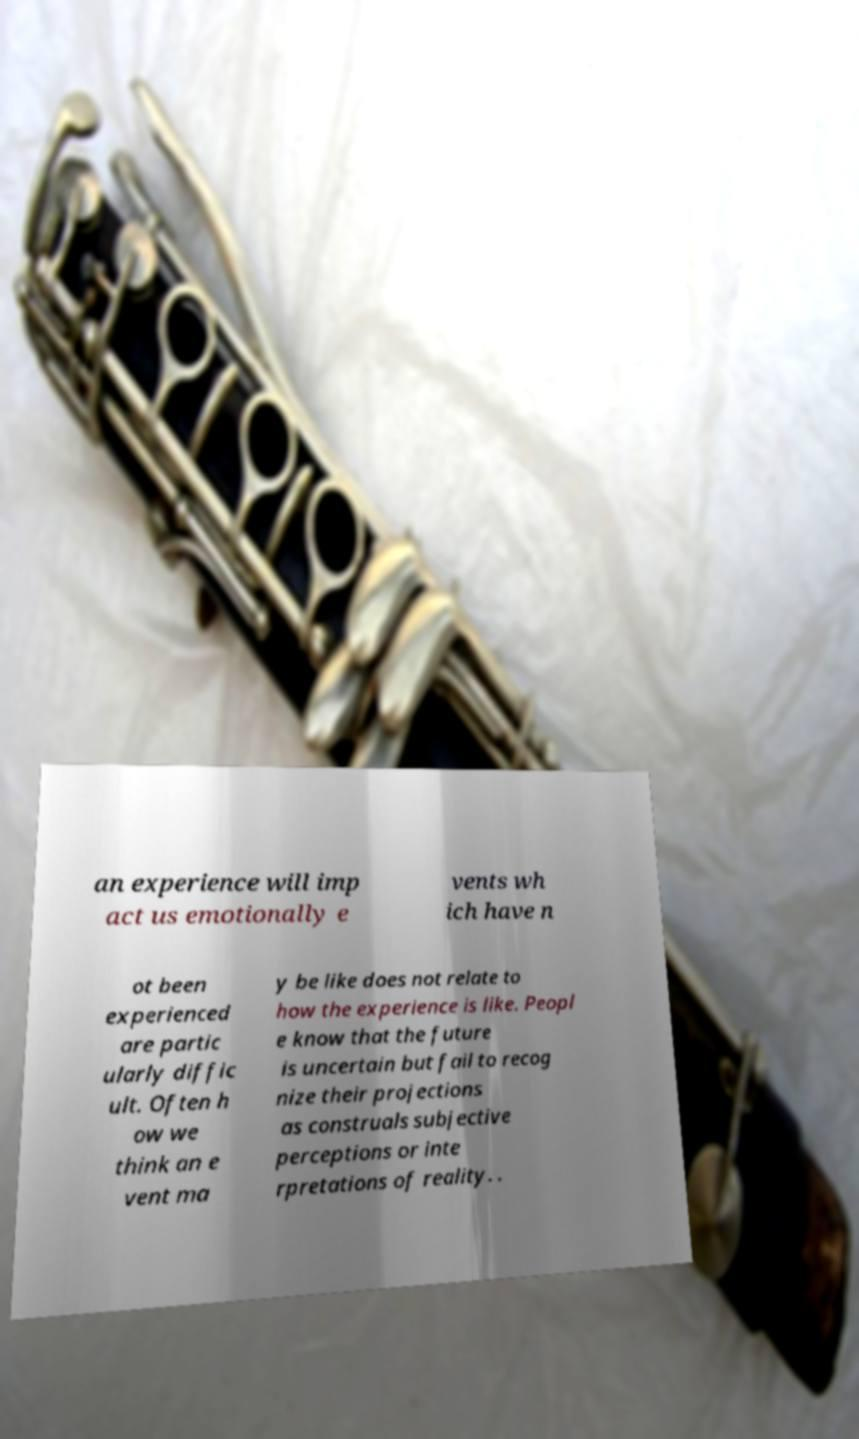Please identify and transcribe the text found in this image. an experience will imp act us emotionally e vents wh ich have n ot been experienced are partic ularly diffic ult. Often h ow we think an e vent ma y be like does not relate to how the experience is like. Peopl e know that the future is uncertain but fail to recog nize their projections as construals subjective perceptions or inte rpretations of reality. . 